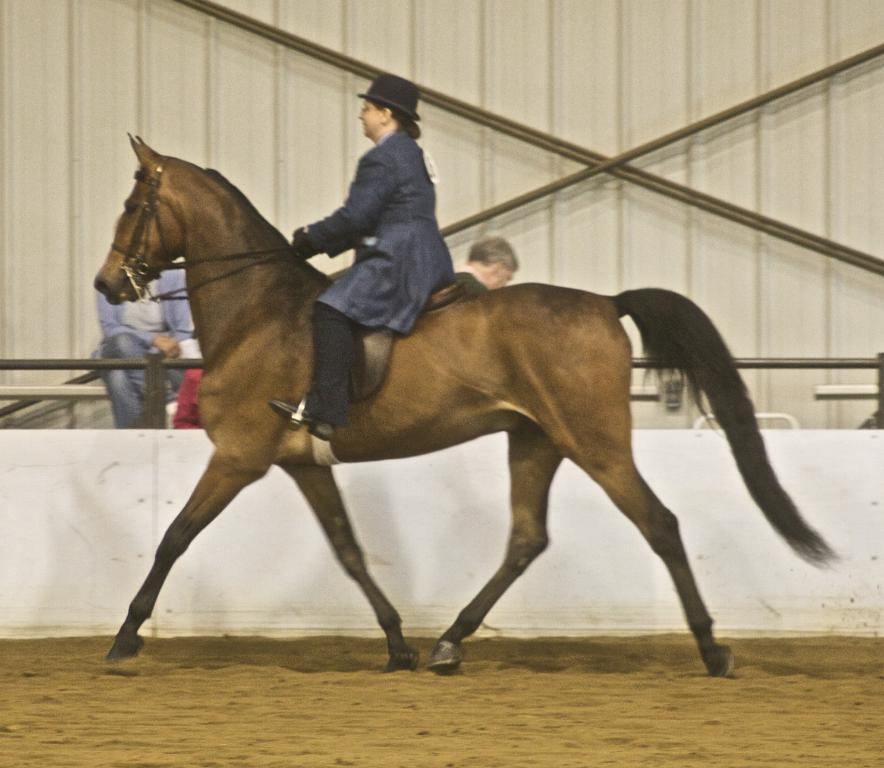Can you describe this image briefly? a person is riding a horse wearing a hat, in the sand. behind her there are people sitting. at the back there is a white wall. 